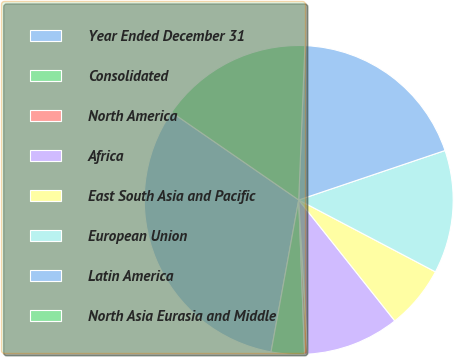<chart> <loc_0><loc_0><loc_500><loc_500><pie_chart><fcel>Year Ended December 31<fcel>Consolidated<fcel>North America<fcel>Africa<fcel>East South Asia and Pacific<fcel>European Union<fcel>Latin America<fcel>North Asia Eurasia and Middle<nl><fcel>31.74%<fcel>3.47%<fcel>0.33%<fcel>9.75%<fcel>6.61%<fcel>12.89%<fcel>19.17%<fcel>16.03%<nl></chart> 